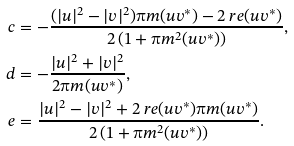Convert formula to latex. <formula><loc_0><loc_0><loc_500><loc_500>c & = - \frac { ( | u | ^ { 2 } - | v | ^ { 2 } ) \i m ( u v ^ { * } ) - 2 \ r e ( u v ^ { * } ) } { 2 \left ( 1 + \i m ^ { 2 } ( u v ^ { * } ) \right ) } , \\ d & = - \frac { | u | ^ { 2 } + | v | ^ { 2 } } { 2 \i m ( u v ^ { * } ) } , \\ e & = \frac { | u | ^ { 2 } - | v | ^ { 2 } + 2 \ r e ( u v ^ { * } ) \i m ( u v ^ { * } ) } { 2 \left ( 1 + \i m ^ { 2 } ( u v ^ { * } ) \right ) } .</formula> 